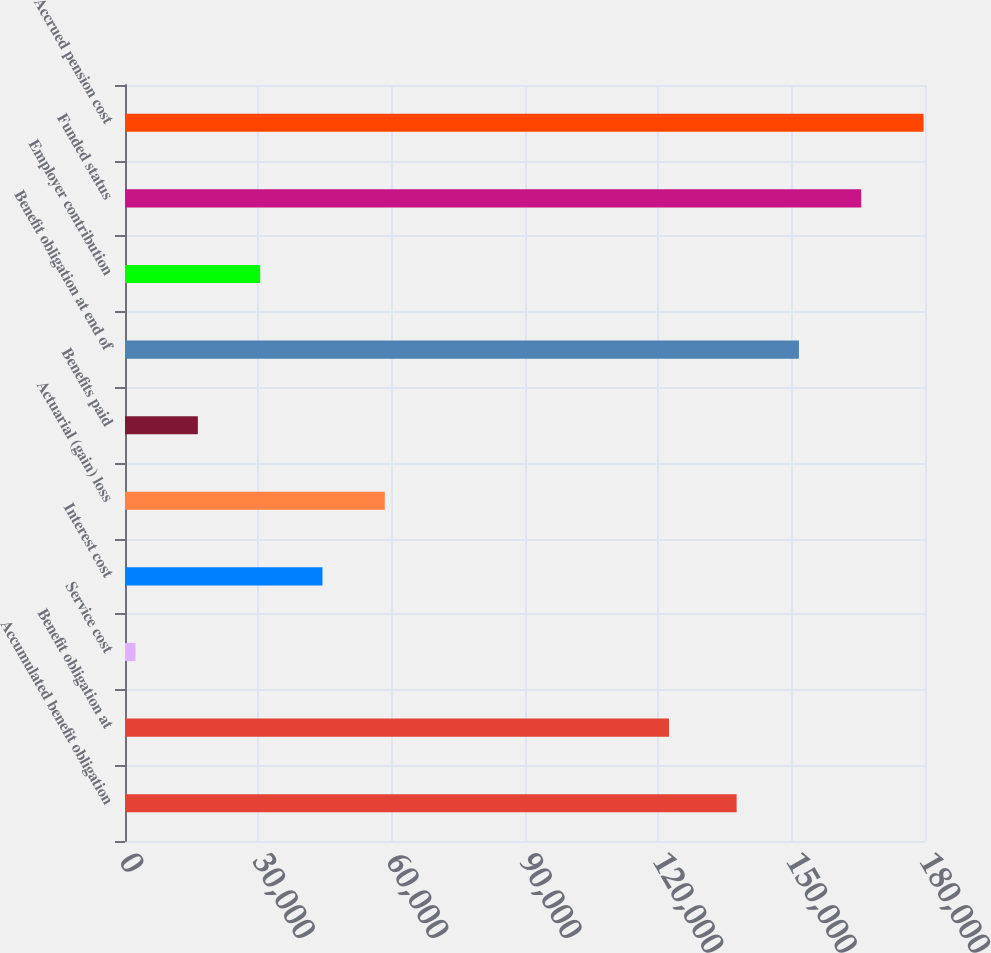<chart> <loc_0><loc_0><loc_500><loc_500><bar_chart><fcel>Accumulated benefit obligation<fcel>Benefit obligation at<fcel>Service cost<fcel>Interest cost<fcel>Actuarial (gain) loss<fcel>Benefits paid<fcel>Benefit obligation at end of<fcel>Employer contribution<fcel>Funded status<fcel>Accrued pension cost<nl><fcel>137616<fcel>122393<fcel>2371<fcel>44431.9<fcel>58452.2<fcel>16391.3<fcel>151636<fcel>30411.6<fcel>165657<fcel>179677<nl></chart> 